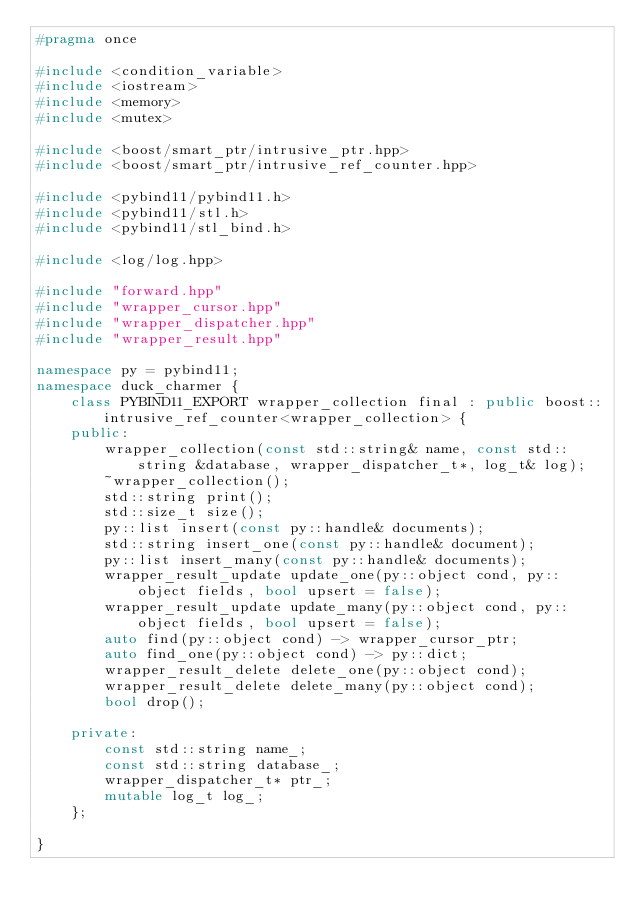<code> <loc_0><loc_0><loc_500><loc_500><_C++_>#pragma once

#include <condition_variable>
#include <iostream>
#include <memory>
#include <mutex>

#include <boost/smart_ptr/intrusive_ptr.hpp>
#include <boost/smart_ptr/intrusive_ref_counter.hpp>

#include <pybind11/pybind11.h>
#include <pybind11/stl.h>
#include <pybind11/stl_bind.h>

#include <log/log.hpp>

#include "forward.hpp"
#include "wrapper_cursor.hpp"
#include "wrapper_dispatcher.hpp"
#include "wrapper_result.hpp"

namespace py = pybind11;
namespace duck_charmer {
    class PYBIND11_EXPORT wrapper_collection final : public boost::intrusive_ref_counter<wrapper_collection> {
    public:
        wrapper_collection(const std::string& name, const std::string &database, wrapper_dispatcher_t*, log_t& log);
        ~wrapper_collection();
        std::string print();
        std::size_t size();
        py::list insert(const py::handle& documents);
        std::string insert_one(const py::handle& document);
        py::list insert_many(const py::handle& documents);
        wrapper_result_update update_one(py::object cond, py::object fields, bool upsert = false);
        wrapper_result_update update_many(py::object cond, py::object fields, bool upsert = false);
        auto find(py::object cond) -> wrapper_cursor_ptr;
        auto find_one(py::object cond) -> py::dict;
        wrapper_result_delete delete_one(py::object cond);
        wrapper_result_delete delete_many(py::object cond);
        bool drop();

    private:
        const std::string name_;
        const std::string database_;
        wrapper_dispatcher_t* ptr_;
        mutable log_t log_;
    };

}
</code> 